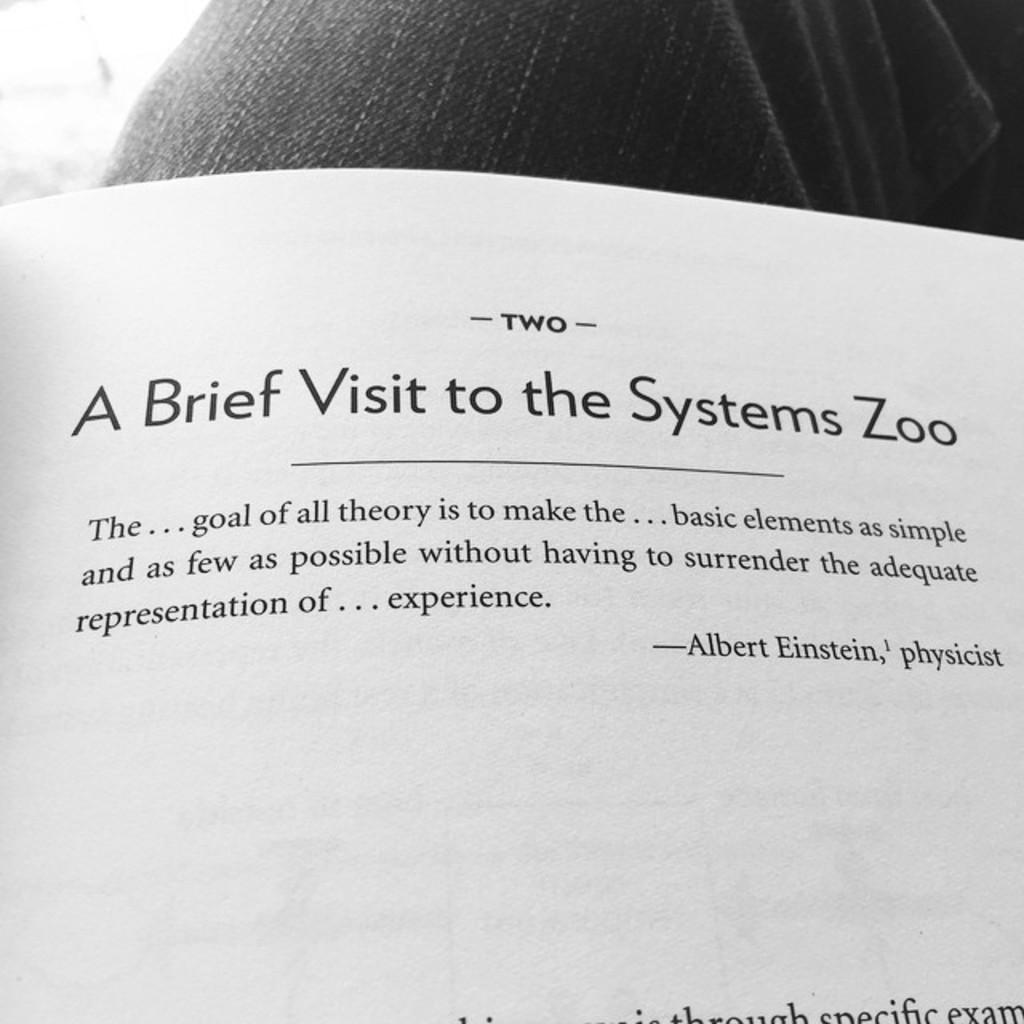What object can be seen in the image? There is a book in the image. What is visible on the pages of the book? There is text visible in the book. What type of stitch is used to bind the pages of the book in the image? There is no information about the stitch used to bind the pages of the book in the image. 